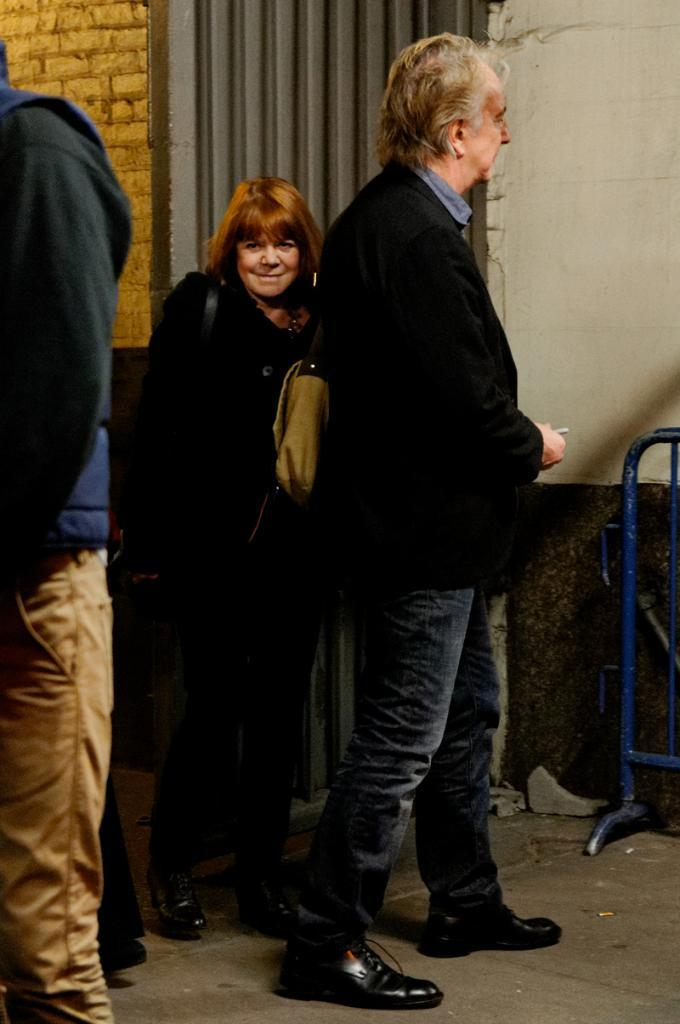What are the people in the image doing? The persons in the image are standing on the floor. What are the man and woman carrying in the image? The man and woman are carrying bags on their shoulders. What can be seen in the background of the image? There is a wall and a stand in the background of the image, along with other objects. What type of vein is visible on the man's forehead in the image? There is no visible vein on the man's forehead in the image. What kind of music is the band playing in the background of the image? There is no band present in the image, so it is not possible to determine what kind of music they might be playing. 